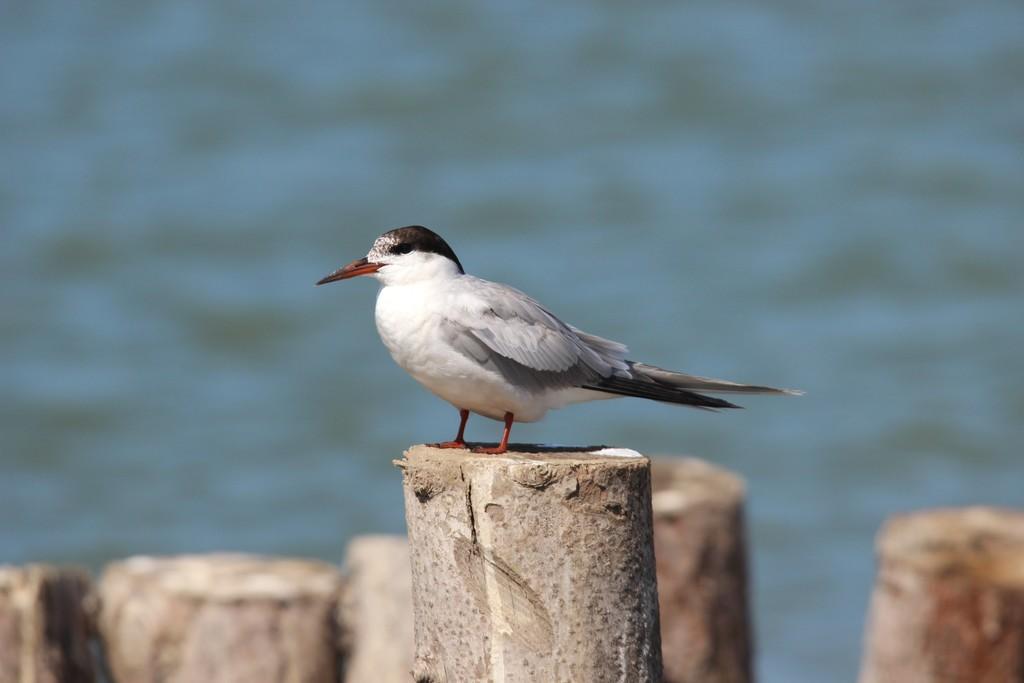How would you summarize this image in a sentence or two? In this picture we can see a bird in the front, there is some wood at the bottom, we can see a blurry background. 